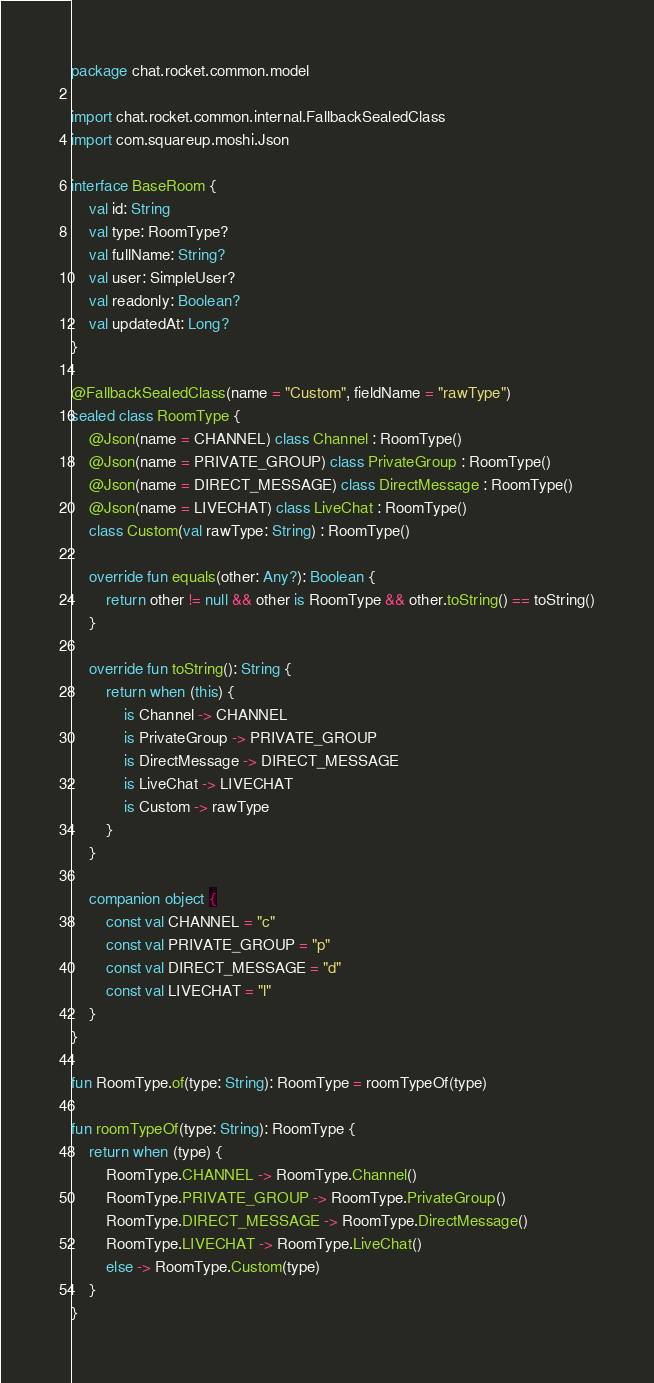<code> <loc_0><loc_0><loc_500><loc_500><_Kotlin_>package chat.rocket.common.model

import chat.rocket.common.internal.FallbackSealedClass
import com.squareup.moshi.Json

interface BaseRoom {
    val id: String
    val type: RoomType?
    val fullName: String?
    val user: SimpleUser?
    val readonly: Boolean?
    val updatedAt: Long?
}

@FallbackSealedClass(name = "Custom", fieldName = "rawType")
sealed class RoomType {
    @Json(name = CHANNEL) class Channel : RoomType()
    @Json(name = PRIVATE_GROUP) class PrivateGroup : RoomType()
    @Json(name = DIRECT_MESSAGE) class DirectMessage : RoomType()
    @Json(name = LIVECHAT) class LiveChat : RoomType()
    class Custom(val rawType: String) : RoomType()

    override fun equals(other: Any?): Boolean {
        return other != null && other is RoomType && other.toString() == toString()
    }

    override fun toString(): String {
        return when (this) {
            is Channel -> CHANNEL
            is PrivateGroup -> PRIVATE_GROUP
            is DirectMessage -> DIRECT_MESSAGE
            is LiveChat -> LIVECHAT
            is Custom -> rawType
        }
    }

    companion object {
        const val CHANNEL = "c"
        const val PRIVATE_GROUP = "p"
        const val DIRECT_MESSAGE = "d"
        const val LIVECHAT = "l"
    }
}

fun RoomType.of(type: String): RoomType = roomTypeOf(type)

fun roomTypeOf(type: String): RoomType {
    return when (type) {
        RoomType.CHANNEL -> RoomType.Channel()
        RoomType.PRIVATE_GROUP -> RoomType.PrivateGroup()
        RoomType.DIRECT_MESSAGE -> RoomType.DirectMessage()
        RoomType.LIVECHAT -> RoomType.LiveChat()
        else -> RoomType.Custom(type)
    }
}</code> 